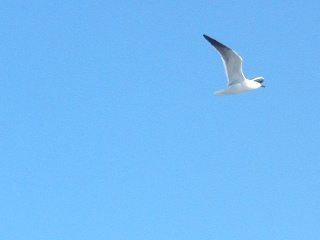What weather conditions appear? The weather conditions appear to be clear and cloudless, with a vivid blue sky. 